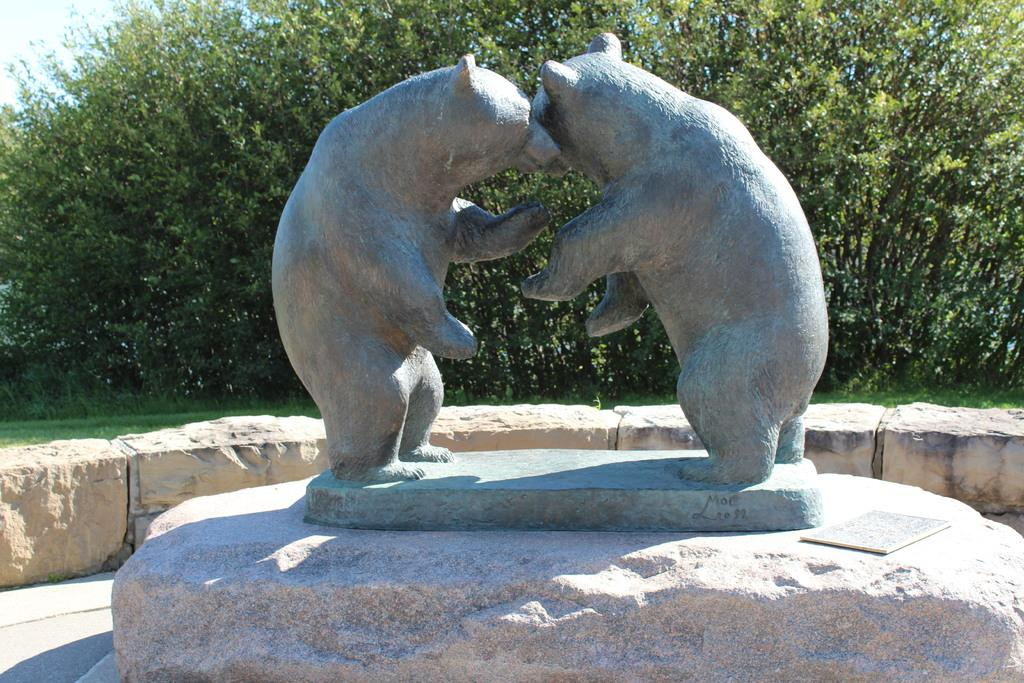What type of animals are depicted as statues in the foreground of the image? There are statues of bears on stone in the foreground of the image. What type of structure can be seen in the image? There is a stone boundary wall in the image. What can be seen in the background of the image? There are trees, grass, and the sky visible in the background of the image. Can you tell me how many ducks are sitting on the stone boundary wall in the image? There are no ducks present on the stone boundary wall in the image. What color crayon is being used to draw the trees in the background of the image? There is no crayon present in the image, as it is a photograph and not a drawing. 